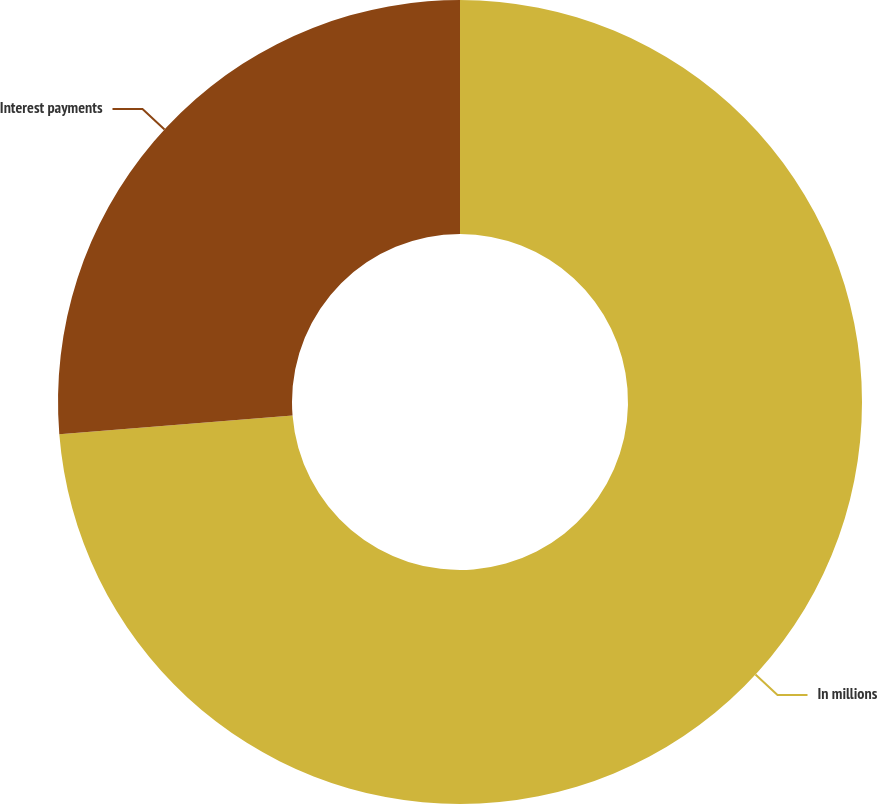Convert chart. <chart><loc_0><loc_0><loc_500><loc_500><pie_chart><fcel>In millions<fcel>Interest payments<nl><fcel>73.72%<fcel>26.28%<nl></chart> 